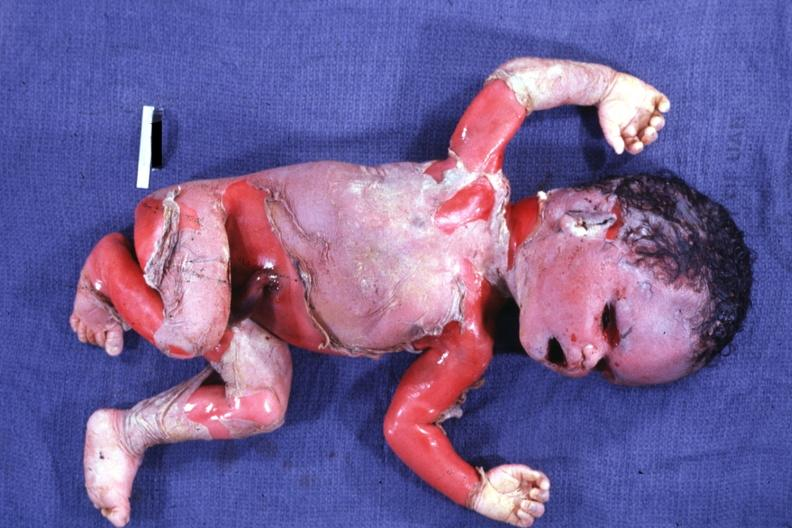what is present?
Answer the question using a single word or phrase. Macerated stillborn 